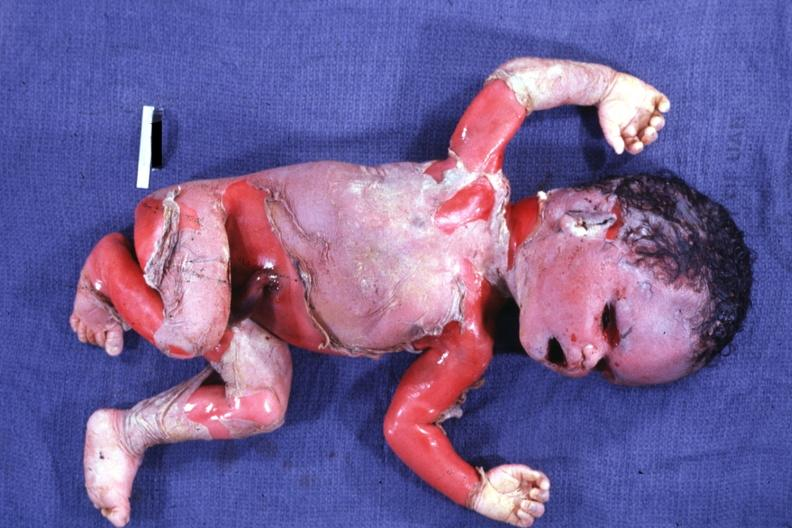what is present?
Answer the question using a single word or phrase. Macerated stillborn 